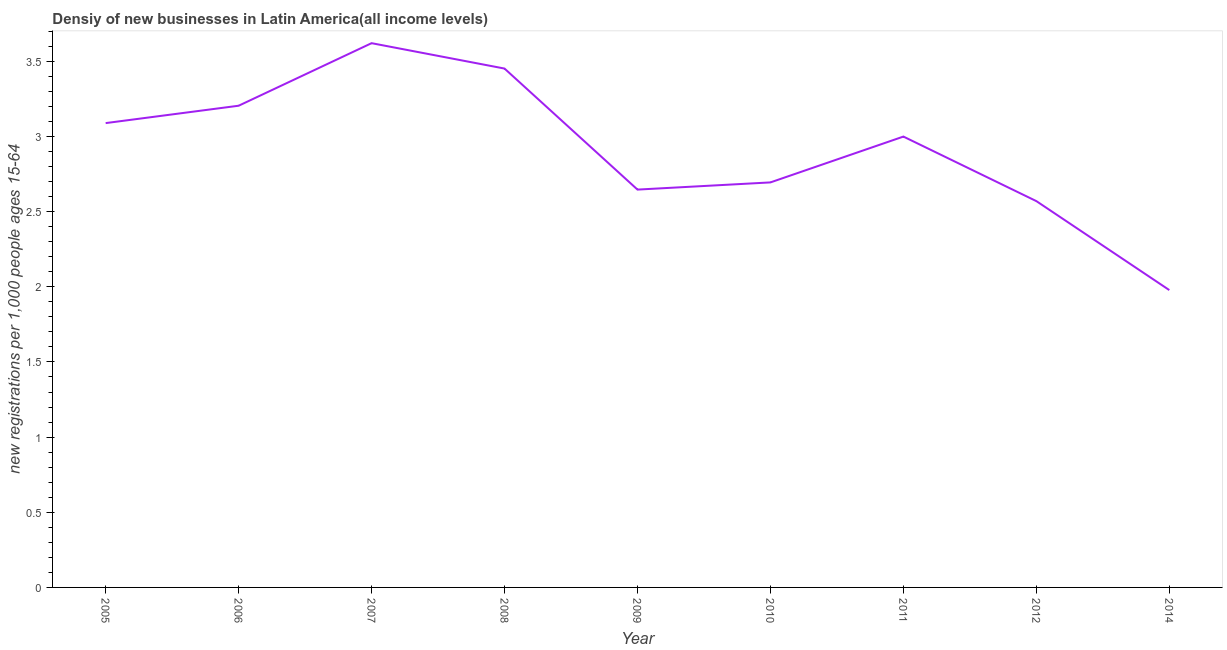What is the density of new business in 2011?
Your answer should be very brief. 3. Across all years, what is the maximum density of new business?
Keep it short and to the point. 3.62. Across all years, what is the minimum density of new business?
Provide a succinct answer. 1.98. In which year was the density of new business maximum?
Provide a succinct answer. 2007. In which year was the density of new business minimum?
Provide a succinct answer. 2014. What is the sum of the density of new business?
Give a very brief answer. 26.25. What is the difference between the density of new business in 2010 and 2014?
Make the answer very short. 0.72. What is the average density of new business per year?
Your response must be concise. 2.92. What is the median density of new business?
Keep it short and to the point. 3. In how many years, is the density of new business greater than 1.5 ?
Your response must be concise. 9. Do a majority of the years between 2012 and 2007 (inclusive) have density of new business greater than 0.4 ?
Offer a very short reply. Yes. What is the ratio of the density of new business in 2006 to that in 2007?
Your answer should be compact. 0.89. What is the difference between the highest and the second highest density of new business?
Your answer should be compact. 0.17. What is the difference between the highest and the lowest density of new business?
Give a very brief answer. 1.64. In how many years, is the density of new business greater than the average density of new business taken over all years?
Provide a succinct answer. 5. How many lines are there?
Offer a very short reply. 1. Are the values on the major ticks of Y-axis written in scientific E-notation?
Offer a terse response. No. Does the graph contain any zero values?
Ensure brevity in your answer.  No. Does the graph contain grids?
Your response must be concise. No. What is the title of the graph?
Offer a very short reply. Densiy of new businesses in Latin America(all income levels). What is the label or title of the Y-axis?
Offer a terse response. New registrations per 1,0 people ages 15-64. What is the new registrations per 1,000 people ages 15-64 of 2005?
Keep it short and to the point. 3.09. What is the new registrations per 1,000 people ages 15-64 of 2006?
Your answer should be compact. 3.2. What is the new registrations per 1,000 people ages 15-64 in 2007?
Ensure brevity in your answer.  3.62. What is the new registrations per 1,000 people ages 15-64 of 2008?
Make the answer very short. 3.45. What is the new registrations per 1,000 people ages 15-64 in 2009?
Provide a succinct answer. 2.65. What is the new registrations per 1,000 people ages 15-64 of 2010?
Give a very brief answer. 2.69. What is the new registrations per 1,000 people ages 15-64 of 2011?
Give a very brief answer. 3. What is the new registrations per 1,000 people ages 15-64 in 2012?
Provide a short and direct response. 2.57. What is the new registrations per 1,000 people ages 15-64 in 2014?
Your answer should be very brief. 1.98. What is the difference between the new registrations per 1,000 people ages 15-64 in 2005 and 2006?
Offer a terse response. -0.12. What is the difference between the new registrations per 1,000 people ages 15-64 in 2005 and 2007?
Ensure brevity in your answer.  -0.53. What is the difference between the new registrations per 1,000 people ages 15-64 in 2005 and 2008?
Ensure brevity in your answer.  -0.36. What is the difference between the new registrations per 1,000 people ages 15-64 in 2005 and 2009?
Offer a very short reply. 0.44. What is the difference between the new registrations per 1,000 people ages 15-64 in 2005 and 2010?
Offer a very short reply. 0.39. What is the difference between the new registrations per 1,000 people ages 15-64 in 2005 and 2011?
Give a very brief answer. 0.09. What is the difference between the new registrations per 1,000 people ages 15-64 in 2005 and 2012?
Offer a very short reply. 0.52. What is the difference between the new registrations per 1,000 people ages 15-64 in 2005 and 2014?
Your answer should be very brief. 1.11. What is the difference between the new registrations per 1,000 people ages 15-64 in 2006 and 2007?
Give a very brief answer. -0.42. What is the difference between the new registrations per 1,000 people ages 15-64 in 2006 and 2008?
Your response must be concise. -0.25. What is the difference between the new registrations per 1,000 people ages 15-64 in 2006 and 2009?
Your answer should be very brief. 0.56. What is the difference between the new registrations per 1,000 people ages 15-64 in 2006 and 2010?
Offer a terse response. 0.51. What is the difference between the new registrations per 1,000 people ages 15-64 in 2006 and 2011?
Provide a short and direct response. 0.21. What is the difference between the new registrations per 1,000 people ages 15-64 in 2006 and 2012?
Offer a very short reply. 0.63. What is the difference between the new registrations per 1,000 people ages 15-64 in 2006 and 2014?
Provide a succinct answer. 1.23. What is the difference between the new registrations per 1,000 people ages 15-64 in 2007 and 2008?
Provide a short and direct response. 0.17. What is the difference between the new registrations per 1,000 people ages 15-64 in 2007 and 2009?
Offer a terse response. 0.97. What is the difference between the new registrations per 1,000 people ages 15-64 in 2007 and 2010?
Ensure brevity in your answer.  0.93. What is the difference between the new registrations per 1,000 people ages 15-64 in 2007 and 2011?
Keep it short and to the point. 0.62. What is the difference between the new registrations per 1,000 people ages 15-64 in 2007 and 2012?
Ensure brevity in your answer.  1.05. What is the difference between the new registrations per 1,000 people ages 15-64 in 2007 and 2014?
Offer a very short reply. 1.64. What is the difference between the new registrations per 1,000 people ages 15-64 in 2008 and 2009?
Your answer should be very brief. 0.81. What is the difference between the new registrations per 1,000 people ages 15-64 in 2008 and 2010?
Offer a terse response. 0.76. What is the difference between the new registrations per 1,000 people ages 15-64 in 2008 and 2011?
Offer a very short reply. 0.45. What is the difference between the new registrations per 1,000 people ages 15-64 in 2008 and 2012?
Make the answer very short. 0.88. What is the difference between the new registrations per 1,000 people ages 15-64 in 2008 and 2014?
Provide a short and direct response. 1.47. What is the difference between the new registrations per 1,000 people ages 15-64 in 2009 and 2010?
Ensure brevity in your answer.  -0.05. What is the difference between the new registrations per 1,000 people ages 15-64 in 2009 and 2011?
Your answer should be very brief. -0.35. What is the difference between the new registrations per 1,000 people ages 15-64 in 2009 and 2012?
Make the answer very short. 0.08. What is the difference between the new registrations per 1,000 people ages 15-64 in 2009 and 2014?
Keep it short and to the point. 0.67. What is the difference between the new registrations per 1,000 people ages 15-64 in 2010 and 2011?
Make the answer very short. -0.3. What is the difference between the new registrations per 1,000 people ages 15-64 in 2010 and 2012?
Make the answer very short. 0.12. What is the difference between the new registrations per 1,000 people ages 15-64 in 2010 and 2014?
Give a very brief answer. 0.72. What is the difference between the new registrations per 1,000 people ages 15-64 in 2011 and 2012?
Ensure brevity in your answer.  0.43. What is the difference between the new registrations per 1,000 people ages 15-64 in 2011 and 2014?
Make the answer very short. 1.02. What is the difference between the new registrations per 1,000 people ages 15-64 in 2012 and 2014?
Your response must be concise. 0.59. What is the ratio of the new registrations per 1,000 people ages 15-64 in 2005 to that in 2007?
Your answer should be very brief. 0.85. What is the ratio of the new registrations per 1,000 people ages 15-64 in 2005 to that in 2008?
Provide a succinct answer. 0.9. What is the ratio of the new registrations per 1,000 people ages 15-64 in 2005 to that in 2009?
Offer a very short reply. 1.17. What is the ratio of the new registrations per 1,000 people ages 15-64 in 2005 to that in 2010?
Your answer should be compact. 1.15. What is the ratio of the new registrations per 1,000 people ages 15-64 in 2005 to that in 2012?
Your response must be concise. 1.2. What is the ratio of the new registrations per 1,000 people ages 15-64 in 2005 to that in 2014?
Your answer should be very brief. 1.56. What is the ratio of the new registrations per 1,000 people ages 15-64 in 2006 to that in 2007?
Ensure brevity in your answer.  0.89. What is the ratio of the new registrations per 1,000 people ages 15-64 in 2006 to that in 2008?
Keep it short and to the point. 0.93. What is the ratio of the new registrations per 1,000 people ages 15-64 in 2006 to that in 2009?
Provide a short and direct response. 1.21. What is the ratio of the new registrations per 1,000 people ages 15-64 in 2006 to that in 2010?
Give a very brief answer. 1.19. What is the ratio of the new registrations per 1,000 people ages 15-64 in 2006 to that in 2011?
Ensure brevity in your answer.  1.07. What is the ratio of the new registrations per 1,000 people ages 15-64 in 2006 to that in 2012?
Your answer should be very brief. 1.25. What is the ratio of the new registrations per 1,000 people ages 15-64 in 2006 to that in 2014?
Keep it short and to the point. 1.62. What is the ratio of the new registrations per 1,000 people ages 15-64 in 2007 to that in 2008?
Provide a succinct answer. 1.05. What is the ratio of the new registrations per 1,000 people ages 15-64 in 2007 to that in 2009?
Offer a very short reply. 1.37. What is the ratio of the new registrations per 1,000 people ages 15-64 in 2007 to that in 2010?
Your answer should be very brief. 1.34. What is the ratio of the new registrations per 1,000 people ages 15-64 in 2007 to that in 2011?
Provide a short and direct response. 1.21. What is the ratio of the new registrations per 1,000 people ages 15-64 in 2007 to that in 2012?
Make the answer very short. 1.41. What is the ratio of the new registrations per 1,000 people ages 15-64 in 2007 to that in 2014?
Provide a short and direct response. 1.83. What is the ratio of the new registrations per 1,000 people ages 15-64 in 2008 to that in 2009?
Your response must be concise. 1.3. What is the ratio of the new registrations per 1,000 people ages 15-64 in 2008 to that in 2010?
Provide a short and direct response. 1.28. What is the ratio of the new registrations per 1,000 people ages 15-64 in 2008 to that in 2011?
Provide a succinct answer. 1.15. What is the ratio of the new registrations per 1,000 people ages 15-64 in 2008 to that in 2012?
Ensure brevity in your answer.  1.34. What is the ratio of the new registrations per 1,000 people ages 15-64 in 2008 to that in 2014?
Give a very brief answer. 1.75. What is the ratio of the new registrations per 1,000 people ages 15-64 in 2009 to that in 2010?
Make the answer very short. 0.98. What is the ratio of the new registrations per 1,000 people ages 15-64 in 2009 to that in 2011?
Offer a terse response. 0.88. What is the ratio of the new registrations per 1,000 people ages 15-64 in 2009 to that in 2012?
Offer a terse response. 1.03. What is the ratio of the new registrations per 1,000 people ages 15-64 in 2009 to that in 2014?
Your response must be concise. 1.34. What is the ratio of the new registrations per 1,000 people ages 15-64 in 2010 to that in 2011?
Your answer should be compact. 0.9. What is the ratio of the new registrations per 1,000 people ages 15-64 in 2010 to that in 2012?
Make the answer very short. 1.05. What is the ratio of the new registrations per 1,000 people ages 15-64 in 2010 to that in 2014?
Ensure brevity in your answer.  1.36. What is the ratio of the new registrations per 1,000 people ages 15-64 in 2011 to that in 2012?
Provide a short and direct response. 1.17. What is the ratio of the new registrations per 1,000 people ages 15-64 in 2011 to that in 2014?
Give a very brief answer. 1.52. What is the ratio of the new registrations per 1,000 people ages 15-64 in 2012 to that in 2014?
Provide a short and direct response. 1.3. 